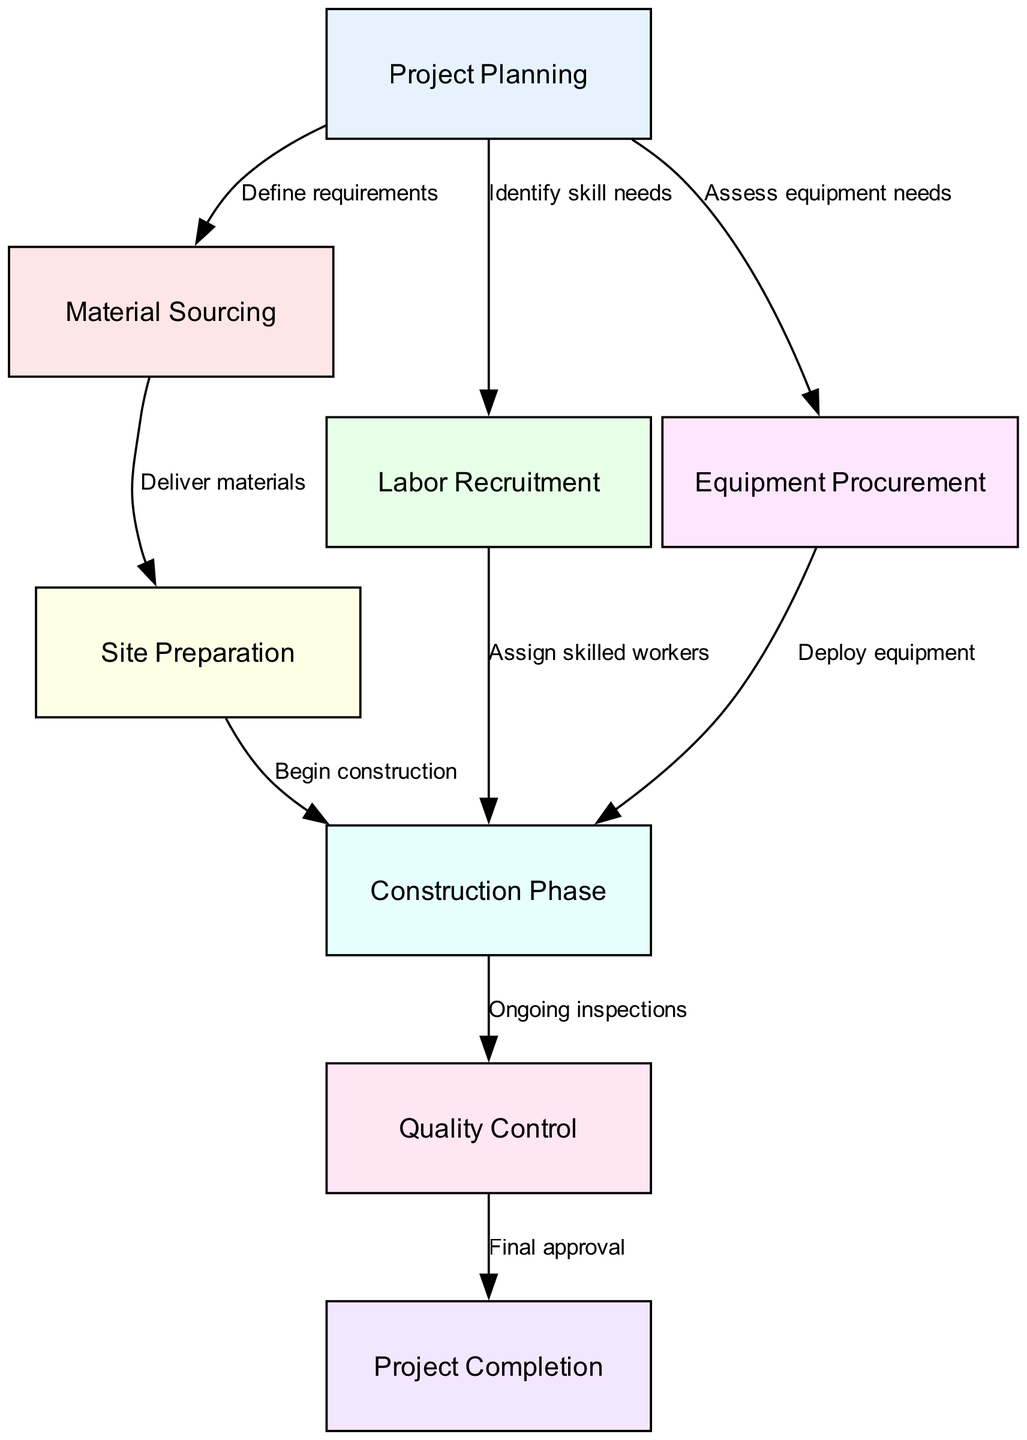What is the first step in the supply chain process? The first step listed in the diagram is "Project Planning," which is identified as the initial node in the flow of the supply chain process.
Answer: Project Planning How many nodes are in the diagram? By counting the unique steps listed in the diagram, there are a total of eight nodes representing different stages in the supply chain process for a construction project.
Answer: 8 What node follows "Material Sourcing"? The diagram shows that after "Material Sourcing," the next node is "Site Preparation," as indicated by the directed edge from the former to the latter.
Answer: Site Preparation What is the label on the edge from "Labor Recruitment" to "Construction Phase"? The label on this edge is "Assign skilled workers," which indicates the specific action that links these two nodes in the supply chain process.
Answer: Assign skilled workers Which nodes are directly connected to "Project Planning"? The nodes connected to "Project Planning" are "Material Sourcing," "Labor Recruitment," and "Equipment Procurement," each linked through a separate directed edge indicating their relationships.
Answer: Material Sourcing, Labor Recruitment, Equipment Procurement What is the last stage of the process? The final stage in the supply chain process is "Project Completion," which is the last node in the flow of the diagram, receiving a directed edge from "Quality Control."
Answer: Project Completion How many edges are there in total? By analyzing the connections between the nodes, there are a total of nine edges describing the interactions and transitions between the various stages in the construction project supply chain.
Answer: 9 What is the relationship between "Quality Control" and "Project Completion"? The relationship is labeled as "Final approval," signifying that the completion of the quality control step leads to the final approval needed for project completion.
Answer: Final approval What is the importance of "Ongoing inspections" in the supply chain? "Ongoing inspections" is crucial as it connects the "Construction Phase" to the "Quality Control," ensuring that the construction work is monitored continuously for quality compliance throughout the project.
Answer: Ongoing inspections 